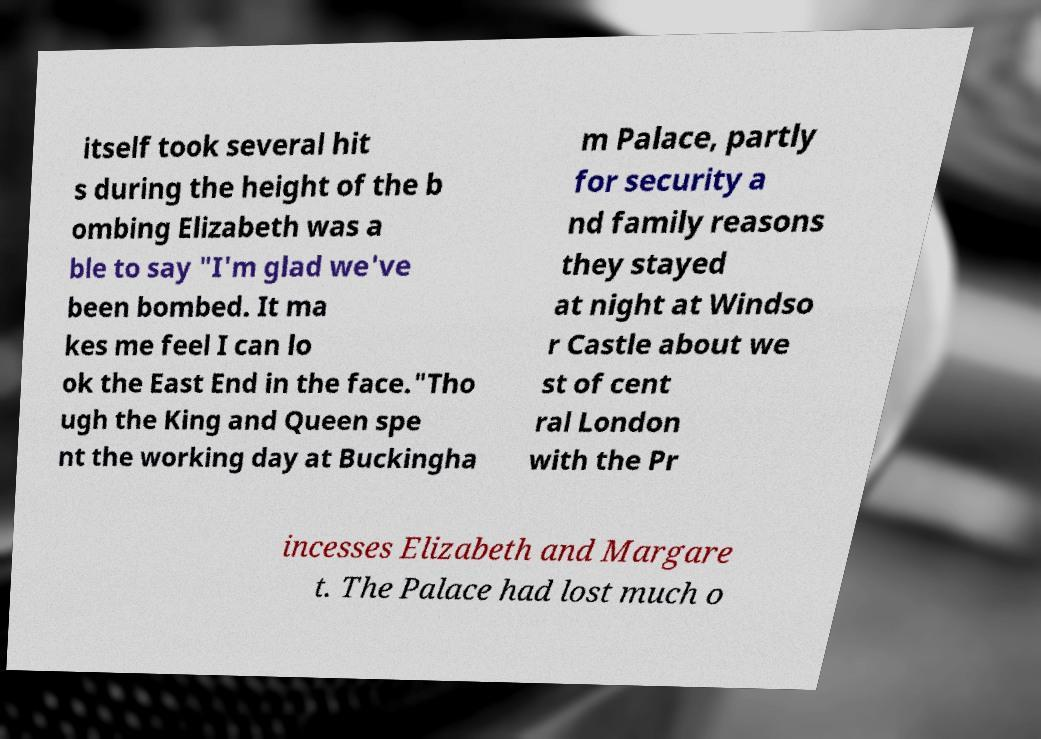Please identify and transcribe the text found in this image. itself took several hit s during the height of the b ombing Elizabeth was a ble to say "I'm glad we've been bombed. It ma kes me feel I can lo ok the East End in the face."Tho ugh the King and Queen spe nt the working day at Buckingha m Palace, partly for security a nd family reasons they stayed at night at Windso r Castle about we st of cent ral London with the Pr incesses Elizabeth and Margare t. The Palace had lost much o 